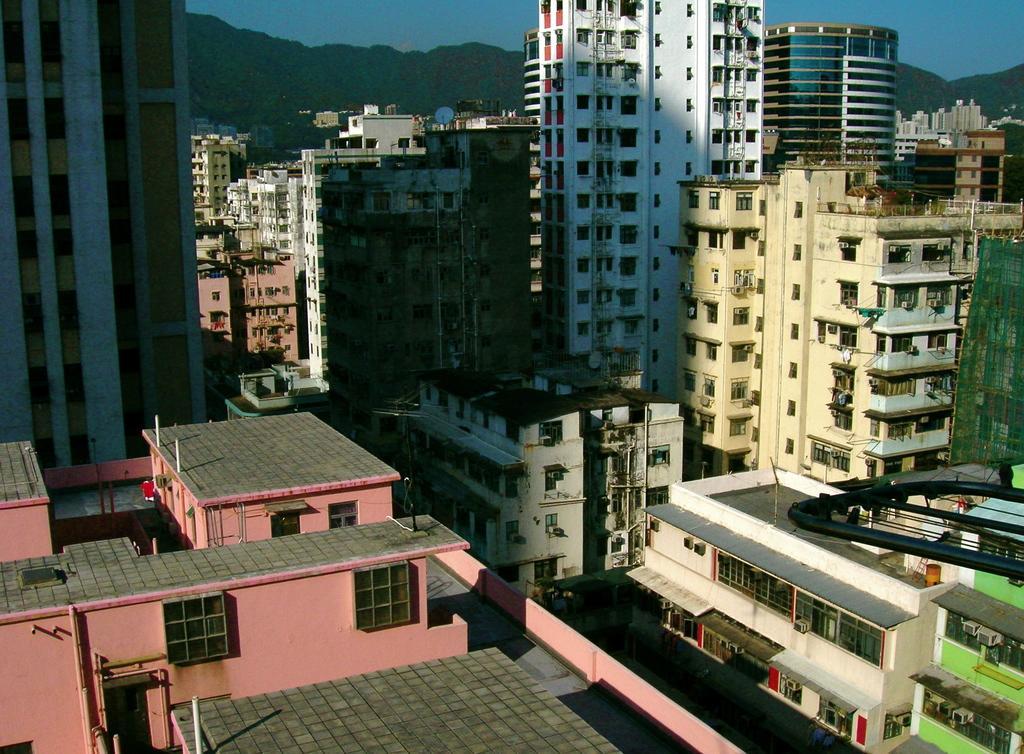In one or two sentences, can you explain what this image depicts? These are the buildings with the windows and glass doors. In the background, I think these are the hills. This looks like a network dish, which is at the top of the building. 